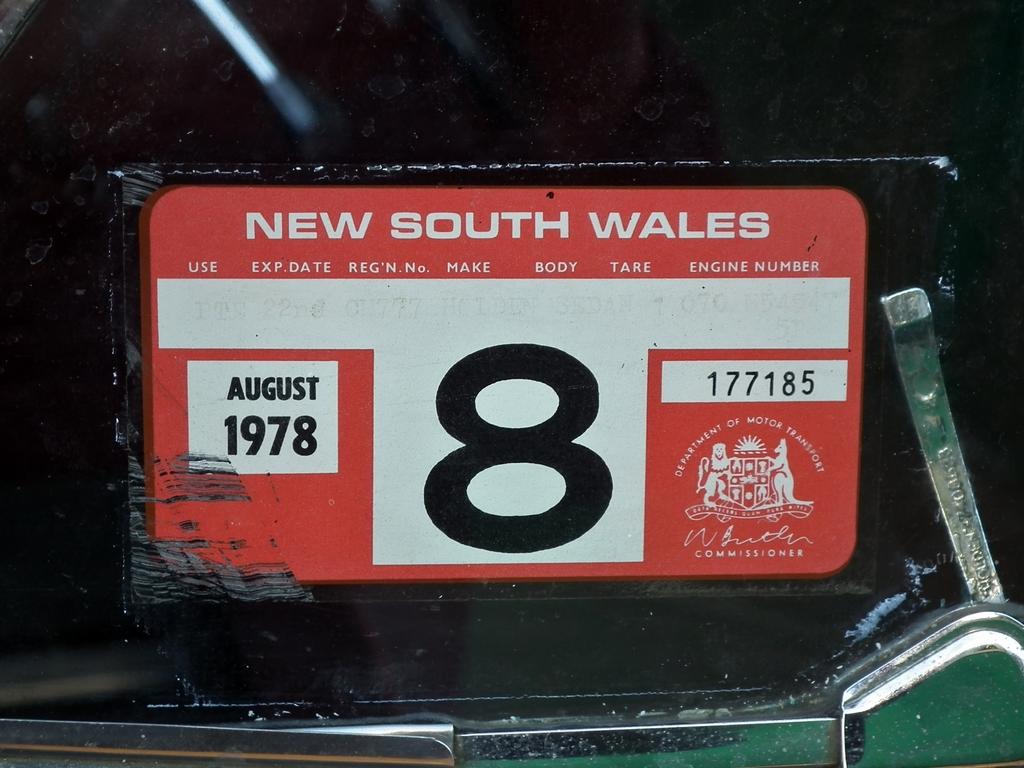What year is stated?
Your response must be concise. 1978. 